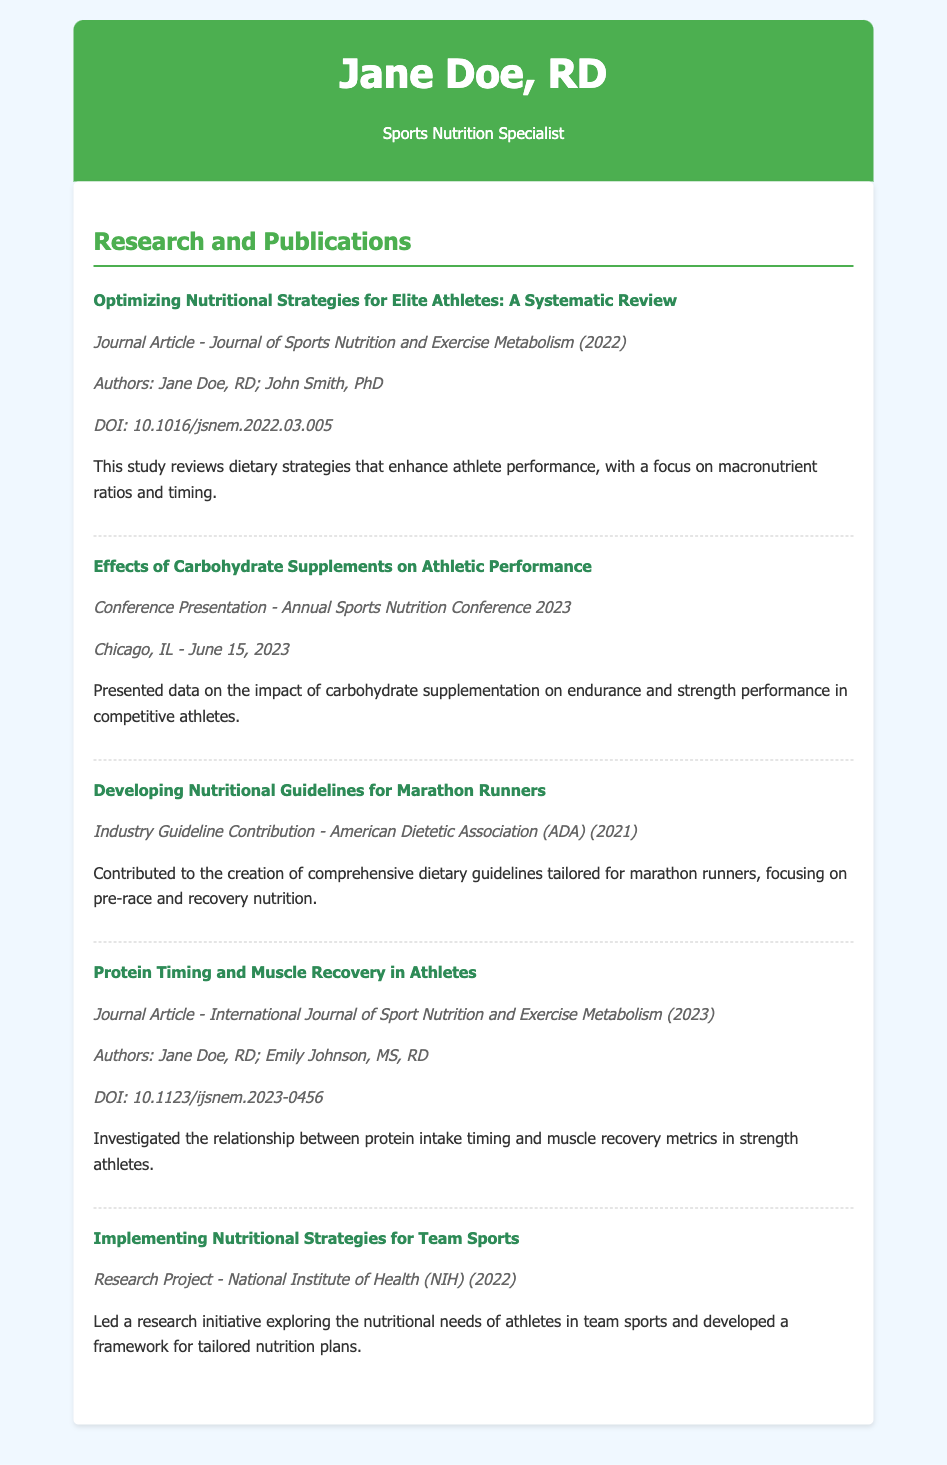What is the title of the first publication? The title of the first publication is listed at the top of the section on research and publications, and it is "Optimizing Nutritional Strategies for Elite Athletes: A Systematic Review."
Answer: Optimizing Nutritional Strategies for Elite Athletes: A Systematic Review In which journal was the first publication published? The first publication was published in the "Journal of Sports Nutrition and Exercise Metabolism," as indicated in the publication details.
Answer: Journal of Sports Nutrition and Exercise Metabolism What year was the conference presentation given? The conference presentation on carbohydrate supplements was given on June 15, 2023, which is mentioned in the publication details.
Answer: 2023 Who are the authors of the article titled "Protein Timing and Muscle Recovery in Athletes"? The authors of this article are listed directly under the title, which includes Jane Doe and Emily Johnson.
Answer: Jane Doe, RD; Emily Johnson, MS, RD What is the focus of the industry guideline contribution related to marathon runners? The focus of this contribution is mentioned in the summary, which emphasizes comprehensive dietary guidelines tailored for marathon runners, especially related to pre-race and recovery nutrition.
Answer: Comprehensive dietary guidelines tailored for marathon runners What type of project was "Implementing Nutritional Strategies for Team Sports"? The type of project is clearly defined in the document as a research project.
Answer: Research Project 